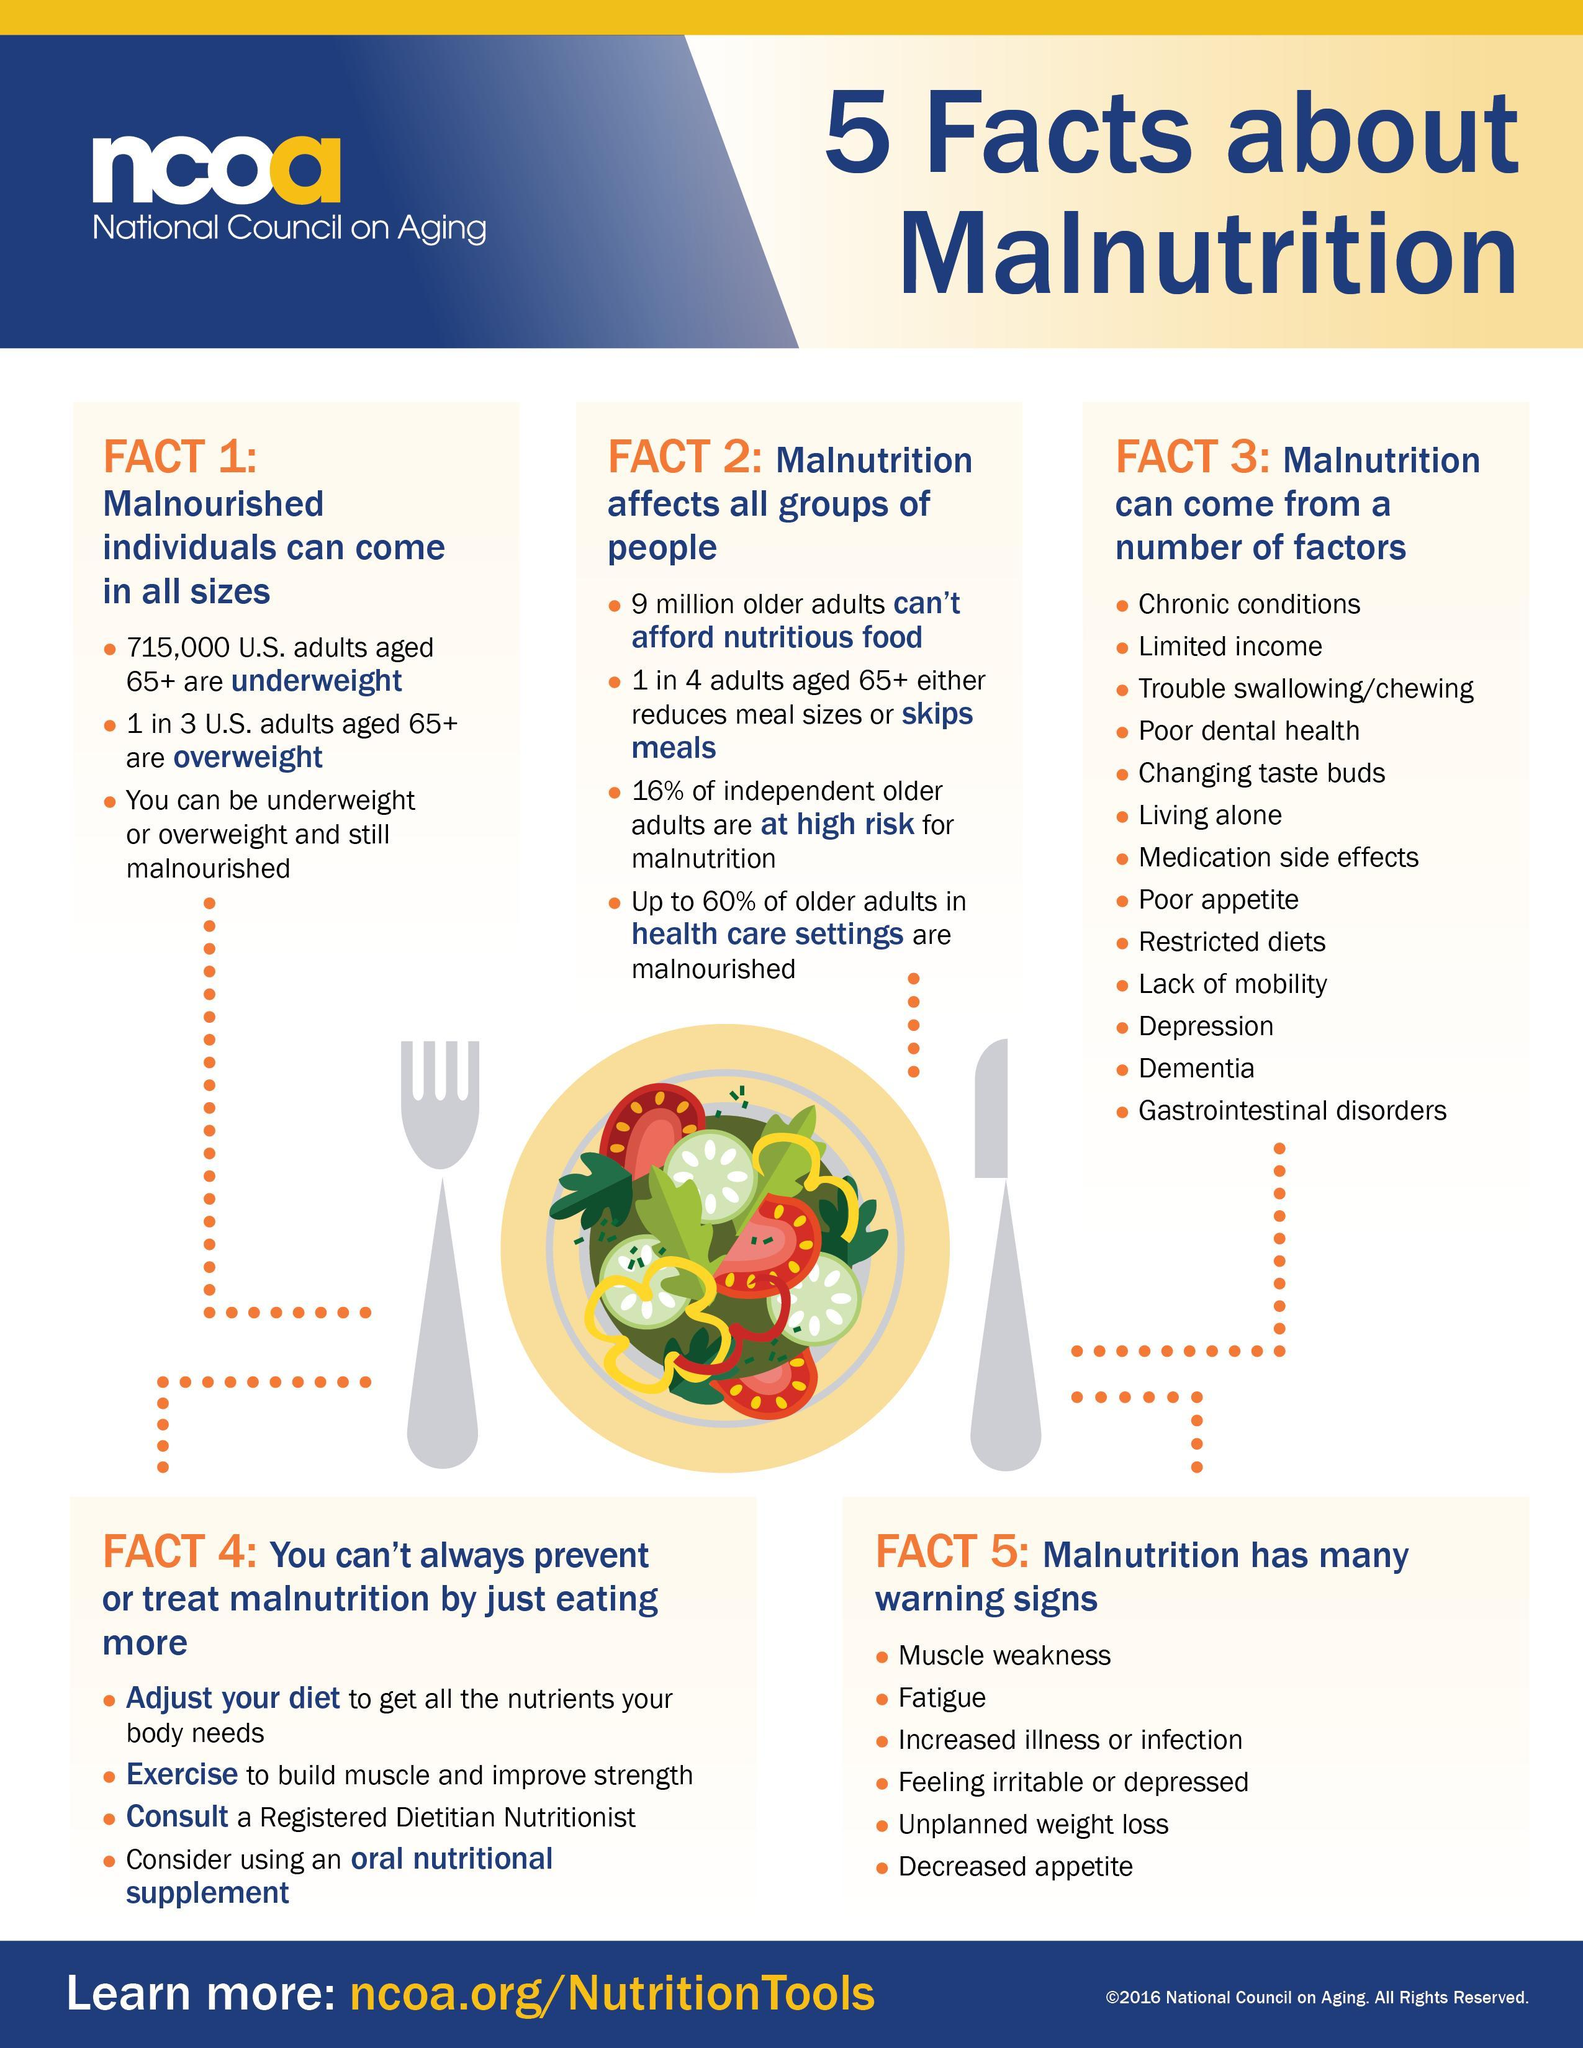What percent of older adults in health care settings are not malnourished?
Answer the question with a short phrase. 40% How many adults aged 65+ in US are not overweight? 2 in 3 How many senior citizens in US are underweight? 715,000 